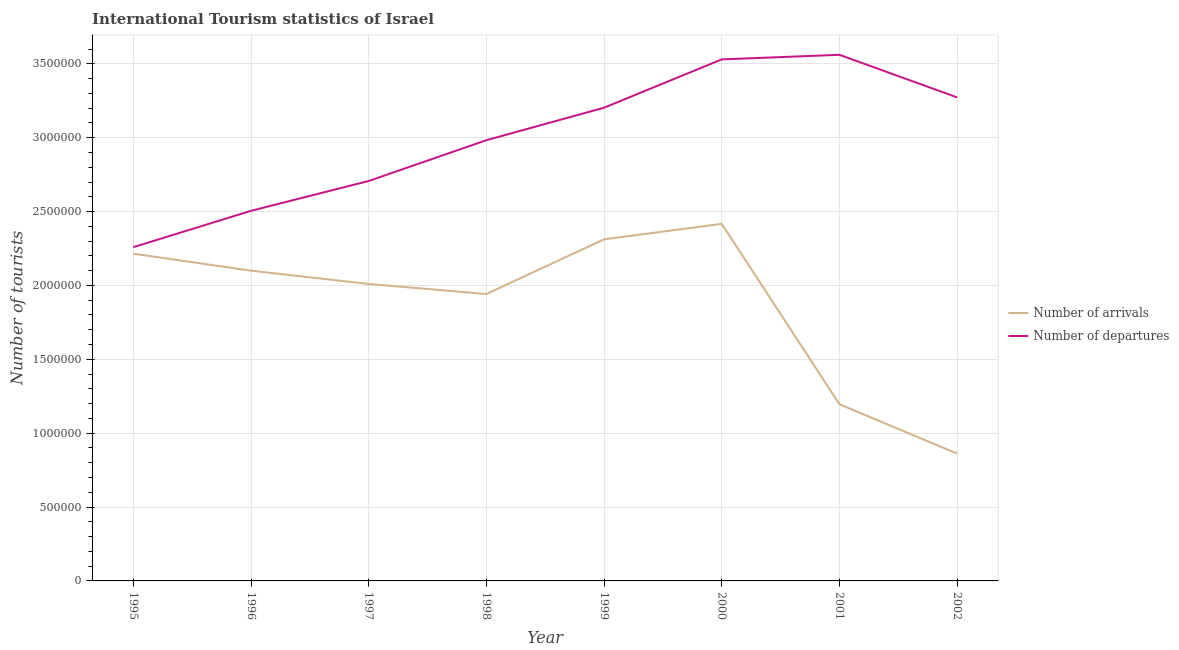What is the number of tourist arrivals in 1999?
Your response must be concise. 2.31e+06. Across all years, what is the maximum number of tourist arrivals?
Offer a very short reply. 2.42e+06. Across all years, what is the minimum number of tourist arrivals?
Provide a short and direct response. 8.62e+05. In which year was the number of tourist departures maximum?
Your response must be concise. 2001. In which year was the number of tourist arrivals minimum?
Provide a succinct answer. 2002. What is the total number of tourist departures in the graph?
Give a very brief answer. 2.40e+07. What is the difference between the number of tourist arrivals in 1995 and that in 2002?
Your answer should be compact. 1.35e+06. What is the difference between the number of tourist arrivals in 1997 and the number of tourist departures in 2002?
Provide a short and direct response. -1.26e+06. What is the average number of tourist arrivals per year?
Your answer should be compact. 1.88e+06. In the year 2001, what is the difference between the number of tourist arrivals and number of tourist departures?
Your answer should be compact. -2.36e+06. In how many years, is the number of tourist departures greater than 300000?
Provide a short and direct response. 8. What is the ratio of the number of tourist arrivals in 2001 to that in 2002?
Ensure brevity in your answer.  1.39. Is the difference between the number of tourist arrivals in 1999 and 2001 greater than the difference between the number of tourist departures in 1999 and 2001?
Give a very brief answer. Yes. What is the difference between the highest and the second highest number of tourist arrivals?
Provide a succinct answer. 1.05e+05. What is the difference between the highest and the lowest number of tourist departures?
Give a very brief answer. 1.30e+06. Is the sum of the number of tourist departures in 1997 and 1999 greater than the maximum number of tourist arrivals across all years?
Ensure brevity in your answer.  Yes. Does the number of tourist departures monotonically increase over the years?
Your answer should be very brief. No. Is the number of tourist arrivals strictly less than the number of tourist departures over the years?
Give a very brief answer. Yes. How many lines are there?
Your response must be concise. 2. How many years are there in the graph?
Provide a short and direct response. 8. What is the difference between two consecutive major ticks on the Y-axis?
Your answer should be very brief. 5.00e+05. Does the graph contain any zero values?
Your answer should be very brief. No. Does the graph contain grids?
Provide a short and direct response. Yes. Where does the legend appear in the graph?
Provide a short and direct response. Center right. How many legend labels are there?
Your answer should be very brief. 2. How are the legend labels stacked?
Keep it short and to the point. Vertical. What is the title of the graph?
Ensure brevity in your answer.  International Tourism statistics of Israel. Does "Highest 10% of population" appear as one of the legend labels in the graph?
Your answer should be compact. No. What is the label or title of the Y-axis?
Keep it short and to the point. Number of tourists. What is the Number of tourists in Number of arrivals in 1995?
Offer a terse response. 2.22e+06. What is the Number of tourists of Number of departures in 1995?
Your answer should be very brief. 2.26e+06. What is the Number of tourists in Number of arrivals in 1996?
Your response must be concise. 2.10e+06. What is the Number of tourists in Number of departures in 1996?
Provide a succinct answer. 2.50e+06. What is the Number of tourists in Number of arrivals in 1997?
Your answer should be compact. 2.01e+06. What is the Number of tourists in Number of departures in 1997?
Keep it short and to the point. 2.71e+06. What is the Number of tourists of Number of arrivals in 1998?
Your answer should be compact. 1.94e+06. What is the Number of tourists of Number of departures in 1998?
Give a very brief answer. 2.98e+06. What is the Number of tourists in Number of arrivals in 1999?
Offer a terse response. 2.31e+06. What is the Number of tourists in Number of departures in 1999?
Your answer should be very brief. 3.20e+06. What is the Number of tourists in Number of arrivals in 2000?
Offer a very short reply. 2.42e+06. What is the Number of tourists in Number of departures in 2000?
Make the answer very short. 3.53e+06. What is the Number of tourists in Number of arrivals in 2001?
Offer a terse response. 1.20e+06. What is the Number of tourists in Number of departures in 2001?
Your response must be concise. 3.56e+06. What is the Number of tourists in Number of arrivals in 2002?
Ensure brevity in your answer.  8.62e+05. What is the Number of tourists in Number of departures in 2002?
Provide a succinct answer. 3.27e+06. Across all years, what is the maximum Number of tourists in Number of arrivals?
Offer a very short reply. 2.42e+06. Across all years, what is the maximum Number of tourists of Number of departures?
Provide a succinct answer. 3.56e+06. Across all years, what is the minimum Number of tourists of Number of arrivals?
Offer a terse response. 8.62e+05. Across all years, what is the minimum Number of tourists in Number of departures?
Offer a very short reply. 2.26e+06. What is the total Number of tourists in Number of arrivals in the graph?
Keep it short and to the point. 1.51e+07. What is the total Number of tourists in Number of departures in the graph?
Your response must be concise. 2.40e+07. What is the difference between the Number of tourists in Number of arrivals in 1995 and that in 1996?
Your response must be concise. 1.15e+05. What is the difference between the Number of tourists in Number of departures in 1995 and that in 1996?
Your answer should be very brief. -2.46e+05. What is the difference between the Number of tourists in Number of arrivals in 1995 and that in 1997?
Your answer should be very brief. 2.05e+05. What is the difference between the Number of tourists of Number of departures in 1995 and that in 1997?
Provide a succinct answer. -4.48e+05. What is the difference between the Number of tourists of Number of arrivals in 1995 and that in 1998?
Give a very brief answer. 2.73e+05. What is the difference between the Number of tourists of Number of departures in 1995 and that in 1998?
Provide a short and direct response. -7.24e+05. What is the difference between the Number of tourists of Number of arrivals in 1995 and that in 1999?
Ensure brevity in your answer.  -9.70e+04. What is the difference between the Number of tourists in Number of departures in 1995 and that in 1999?
Your answer should be very brief. -9.44e+05. What is the difference between the Number of tourists in Number of arrivals in 1995 and that in 2000?
Make the answer very short. -2.02e+05. What is the difference between the Number of tourists in Number of departures in 1995 and that in 2000?
Ensure brevity in your answer.  -1.27e+06. What is the difference between the Number of tourists of Number of arrivals in 1995 and that in 2001?
Offer a terse response. 1.02e+06. What is the difference between the Number of tourists of Number of departures in 1995 and that in 2001?
Make the answer very short. -1.30e+06. What is the difference between the Number of tourists of Number of arrivals in 1995 and that in 2002?
Provide a succinct answer. 1.35e+06. What is the difference between the Number of tourists in Number of departures in 1995 and that in 2002?
Your answer should be very brief. -1.01e+06. What is the difference between the Number of tourists of Number of departures in 1996 and that in 1997?
Your answer should be compact. -2.02e+05. What is the difference between the Number of tourists in Number of arrivals in 1996 and that in 1998?
Keep it short and to the point. 1.58e+05. What is the difference between the Number of tourists in Number of departures in 1996 and that in 1998?
Your answer should be compact. -4.78e+05. What is the difference between the Number of tourists of Number of arrivals in 1996 and that in 1999?
Your answer should be compact. -2.12e+05. What is the difference between the Number of tourists in Number of departures in 1996 and that in 1999?
Your answer should be very brief. -6.98e+05. What is the difference between the Number of tourists of Number of arrivals in 1996 and that in 2000?
Provide a succinct answer. -3.17e+05. What is the difference between the Number of tourists in Number of departures in 1996 and that in 2000?
Offer a very short reply. -1.02e+06. What is the difference between the Number of tourists in Number of arrivals in 1996 and that in 2001?
Keep it short and to the point. 9.04e+05. What is the difference between the Number of tourists in Number of departures in 1996 and that in 2001?
Make the answer very short. -1.06e+06. What is the difference between the Number of tourists of Number of arrivals in 1996 and that in 2002?
Make the answer very short. 1.24e+06. What is the difference between the Number of tourists in Number of departures in 1996 and that in 2002?
Give a very brief answer. -7.68e+05. What is the difference between the Number of tourists of Number of arrivals in 1997 and that in 1998?
Your response must be concise. 6.80e+04. What is the difference between the Number of tourists of Number of departures in 1997 and that in 1998?
Provide a short and direct response. -2.76e+05. What is the difference between the Number of tourists of Number of arrivals in 1997 and that in 1999?
Keep it short and to the point. -3.02e+05. What is the difference between the Number of tourists in Number of departures in 1997 and that in 1999?
Your answer should be very brief. -4.96e+05. What is the difference between the Number of tourists of Number of arrivals in 1997 and that in 2000?
Make the answer very short. -4.07e+05. What is the difference between the Number of tourists of Number of departures in 1997 and that in 2000?
Make the answer very short. -8.23e+05. What is the difference between the Number of tourists of Number of arrivals in 1997 and that in 2001?
Offer a very short reply. 8.14e+05. What is the difference between the Number of tourists of Number of departures in 1997 and that in 2001?
Offer a terse response. -8.54e+05. What is the difference between the Number of tourists of Number of arrivals in 1997 and that in 2002?
Ensure brevity in your answer.  1.15e+06. What is the difference between the Number of tourists in Number of departures in 1997 and that in 2002?
Provide a succinct answer. -5.66e+05. What is the difference between the Number of tourists in Number of arrivals in 1998 and that in 1999?
Ensure brevity in your answer.  -3.70e+05. What is the difference between the Number of tourists of Number of arrivals in 1998 and that in 2000?
Ensure brevity in your answer.  -4.75e+05. What is the difference between the Number of tourists of Number of departures in 1998 and that in 2000?
Your response must be concise. -5.47e+05. What is the difference between the Number of tourists of Number of arrivals in 1998 and that in 2001?
Ensure brevity in your answer.  7.46e+05. What is the difference between the Number of tourists of Number of departures in 1998 and that in 2001?
Your answer should be compact. -5.78e+05. What is the difference between the Number of tourists of Number of arrivals in 1998 and that in 2002?
Provide a short and direct response. 1.08e+06. What is the difference between the Number of tourists of Number of arrivals in 1999 and that in 2000?
Provide a succinct answer. -1.05e+05. What is the difference between the Number of tourists of Number of departures in 1999 and that in 2000?
Provide a succinct answer. -3.27e+05. What is the difference between the Number of tourists of Number of arrivals in 1999 and that in 2001?
Give a very brief answer. 1.12e+06. What is the difference between the Number of tourists of Number of departures in 1999 and that in 2001?
Your answer should be compact. -3.58e+05. What is the difference between the Number of tourists of Number of arrivals in 1999 and that in 2002?
Ensure brevity in your answer.  1.45e+06. What is the difference between the Number of tourists in Number of arrivals in 2000 and that in 2001?
Give a very brief answer. 1.22e+06. What is the difference between the Number of tourists in Number of departures in 2000 and that in 2001?
Provide a succinct answer. -3.10e+04. What is the difference between the Number of tourists in Number of arrivals in 2000 and that in 2002?
Keep it short and to the point. 1.56e+06. What is the difference between the Number of tourists of Number of departures in 2000 and that in 2002?
Keep it short and to the point. 2.57e+05. What is the difference between the Number of tourists in Number of arrivals in 2001 and that in 2002?
Make the answer very short. 3.34e+05. What is the difference between the Number of tourists of Number of departures in 2001 and that in 2002?
Give a very brief answer. 2.88e+05. What is the difference between the Number of tourists of Number of arrivals in 1995 and the Number of tourists of Number of departures in 1996?
Your answer should be very brief. -2.90e+05. What is the difference between the Number of tourists in Number of arrivals in 1995 and the Number of tourists in Number of departures in 1997?
Provide a succinct answer. -4.92e+05. What is the difference between the Number of tourists of Number of arrivals in 1995 and the Number of tourists of Number of departures in 1998?
Your answer should be compact. -7.68e+05. What is the difference between the Number of tourists of Number of arrivals in 1995 and the Number of tourists of Number of departures in 1999?
Provide a short and direct response. -9.88e+05. What is the difference between the Number of tourists in Number of arrivals in 1995 and the Number of tourists in Number of departures in 2000?
Your answer should be very brief. -1.32e+06. What is the difference between the Number of tourists in Number of arrivals in 1995 and the Number of tourists in Number of departures in 2001?
Your answer should be compact. -1.35e+06. What is the difference between the Number of tourists of Number of arrivals in 1995 and the Number of tourists of Number of departures in 2002?
Keep it short and to the point. -1.06e+06. What is the difference between the Number of tourists in Number of arrivals in 1996 and the Number of tourists in Number of departures in 1997?
Make the answer very short. -6.07e+05. What is the difference between the Number of tourists in Number of arrivals in 1996 and the Number of tourists in Number of departures in 1998?
Ensure brevity in your answer.  -8.83e+05. What is the difference between the Number of tourists of Number of arrivals in 1996 and the Number of tourists of Number of departures in 1999?
Offer a terse response. -1.10e+06. What is the difference between the Number of tourists of Number of arrivals in 1996 and the Number of tourists of Number of departures in 2000?
Your answer should be very brief. -1.43e+06. What is the difference between the Number of tourists in Number of arrivals in 1996 and the Number of tourists in Number of departures in 2001?
Offer a very short reply. -1.46e+06. What is the difference between the Number of tourists of Number of arrivals in 1996 and the Number of tourists of Number of departures in 2002?
Your answer should be very brief. -1.17e+06. What is the difference between the Number of tourists of Number of arrivals in 1997 and the Number of tourists of Number of departures in 1998?
Provide a short and direct response. -9.73e+05. What is the difference between the Number of tourists in Number of arrivals in 1997 and the Number of tourists in Number of departures in 1999?
Provide a succinct answer. -1.19e+06. What is the difference between the Number of tourists of Number of arrivals in 1997 and the Number of tourists of Number of departures in 2000?
Offer a very short reply. -1.52e+06. What is the difference between the Number of tourists of Number of arrivals in 1997 and the Number of tourists of Number of departures in 2001?
Ensure brevity in your answer.  -1.55e+06. What is the difference between the Number of tourists in Number of arrivals in 1997 and the Number of tourists in Number of departures in 2002?
Make the answer very short. -1.26e+06. What is the difference between the Number of tourists of Number of arrivals in 1998 and the Number of tourists of Number of departures in 1999?
Your answer should be very brief. -1.26e+06. What is the difference between the Number of tourists in Number of arrivals in 1998 and the Number of tourists in Number of departures in 2000?
Offer a terse response. -1.59e+06. What is the difference between the Number of tourists in Number of arrivals in 1998 and the Number of tourists in Number of departures in 2001?
Offer a terse response. -1.62e+06. What is the difference between the Number of tourists of Number of arrivals in 1998 and the Number of tourists of Number of departures in 2002?
Your answer should be compact. -1.33e+06. What is the difference between the Number of tourists of Number of arrivals in 1999 and the Number of tourists of Number of departures in 2000?
Give a very brief answer. -1.22e+06. What is the difference between the Number of tourists of Number of arrivals in 1999 and the Number of tourists of Number of departures in 2001?
Provide a succinct answer. -1.25e+06. What is the difference between the Number of tourists in Number of arrivals in 1999 and the Number of tourists in Number of departures in 2002?
Provide a short and direct response. -9.61e+05. What is the difference between the Number of tourists of Number of arrivals in 2000 and the Number of tourists of Number of departures in 2001?
Your response must be concise. -1.14e+06. What is the difference between the Number of tourists in Number of arrivals in 2000 and the Number of tourists in Number of departures in 2002?
Keep it short and to the point. -8.56e+05. What is the difference between the Number of tourists in Number of arrivals in 2001 and the Number of tourists in Number of departures in 2002?
Your response must be concise. -2.08e+06. What is the average Number of tourists of Number of arrivals per year?
Offer a very short reply. 1.88e+06. What is the average Number of tourists in Number of departures per year?
Provide a succinct answer. 3.00e+06. In the year 1995, what is the difference between the Number of tourists in Number of arrivals and Number of tourists in Number of departures?
Ensure brevity in your answer.  -4.40e+04. In the year 1996, what is the difference between the Number of tourists of Number of arrivals and Number of tourists of Number of departures?
Provide a short and direct response. -4.05e+05. In the year 1997, what is the difference between the Number of tourists of Number of arrivals and Number of tourists of Number of departures?
Provide a succinct answer. -6.97e+05. In the year 1998, what is the difference between the Number of tourists of Number of arrivals and Number of tourists of Number of departures?
Make the answer very short. -1.04e+06. In the year 1999, what is the difference between the Number of tourists of Number of arrivals and Number of tourists of Number of departures?
Ensure brevity in your answer.  -8.91e+05. In the year 2000, what is the difference between the Number of tourists of Number of arrivals and Number of tourists of Number of departures?
Ensure brevity in your answer.  -1.11e+06. In the year 2001, what is the difference between the Number of tourists of Number of arrivals and Number of tourists of Number of departures?
Ensure brevity in your answer.  -2.36e+06. In the year 2002, what is the difference between the Number of tourists of Number of arrivals and Number of tourists of Number of departures?
Your answer should be compact. -2.41e+06. What is the ratio of the Number of tourists in Number of arrivals in 1995 to that in 1996?
Give a very brief answer. 1.05. What is the ratio of the Number of tourists of Number of departures in 1995 to that in 1996?
Your response must be concise. 0.9. What is the ratio of the Number of tourists of Number of arrivals in 1995 to that in 1997?
Offer a very short reply. 1.1. What is the ratio of the Number of tourists of Number of departures in 1995 to that in 1997?
Your response must be concise. 0.83. What is the ratio of the Number of tourists in Number of arrivals in 1995 to that in 1998?
Offer a very short reply. 1.14. What is the ratio of the Number of tourists of Number of departures in 1995 to that in 1998?
Give a very brief answer. 0.76. What is the ratio of the Number of tourists in Number of arrivals in 1995 to that in 1999?
Ensure brevity in your answer.  0.96. What is the ratio of the Number of tourists in Number of departures in 1995 to that in 1999?
Your answer should be very brief. 0.71. What is the ratio of the Number of tourists in Number of arrivals in 1995 to that in 2000?
Your answer should be very brief. 0.92. What is the ratio of the Number of tourists of Number of departures in 1995 to that in 2000?
Your answer should be compact. 0.64. What is the ratio of the Number of tourists of Number of arrivals in 1995 to that in 2001?
Offer a terse response. 1.85. What is the ratio of the Number of tourists in Number of departures in 1995 to that in 2001?
Give a very brief answer. 0.63. What is the ratio of the Number of tourists of Number of arrivals in 1995 to that in 2002?
Offer a terse response. 2.57. What is the ratio of the Number of tourists of Number of departures in 1995 to that in 2002?
Keep it short and to the point. 0.69. What is the ratio of the Number of tourists in Number of arrivals in 1996 to that in 1997?
Offer a very short reply. 1.04. What is the ratio of the Number of tourists in Number of departures in 1996 to that in 1997?
Ensure brevity in your answer.  0.93. What is the ratio of the Number of tourists of Number of arrivals in 1996 to that in 1998?
Keep it short and to the point. 1.08. What is the ratio of the Number of tourists in Number of departures in 1996 to that in 1998?
Give a very brief answer. 0.84. What is the ratio of the Number of tourists in Number of arrivals in 1996 to that in 1999?
Your answer should be compact. 0.91. What is the ratio of the Number of tourists of Number of departures in 1996 to that in 1999?
Offer a very short reply. 0.78. What is the ratio of the Number of tourists of Number of arrivals in 1996 to that in 2000?
Provide a succinct answer. 0.87. What is the ratio of the Number of tourists of Number of departures in 1996 to that in 2000?
Keep it short and to the point. 0.71. What is the ratio of the Number of tourists of Number of arrivals in 1996 to that in 2001?
Ensure brevity in your answer.  1.76. What is the ratio of the Number of tourists in Number of departures in 1996 to that in 2001?
Provide a short and direct response. 0.7. What is the ratio of the Number of tourists in Number of arrivals in 1996 to that in 2002?
Your response must be concise. 2.44. What is the ratio of the Number of tourists of Number of departures in 1996 to that in 2002?
Provide a succinct answer. 0.77. What is the ratio of the Number of tourists of Number of arrivals in 1997 to that in 1998?
Ensure brevity in your answer.  1.03. What is the ratio of the Number of tourists in Number of departures in 1997 to that in 1998?
Provide a succinct answer. 0.91. What is the ratio of the Number of tourists in Number of arrivals in 1997 to that in 1999?
Provide a short and direct response. 0.87. What is the ratio of the Number of tourists of Number of departures in 1997 to that in 1999?
Offer a very short reply. 0.85. What is the ratio of the Number of tourists in Number of arrivals in 1997 to that in 2000?
Ensure brevity in your answer.  0.83. What is the ratio of the Number of tourists of Number of departures in 1997 to that in 2000?
Your response must be concise. 0.77. What is the ratio of the Number of tourists in Number of arrivals in 1997 to that in 2001?
Give a very brief answer. 1.68. What is the ratio of the Number of tourists in Number of departures in 1997 to that in 2001?
Give a very brief answer. 0.76. What is the ratio of the Number of tourists in Number of arrivals in 1997 to that in 2002?
Give a very brief answer. 2.33. What is the ratio of the Number of tourists in Number of departures in 1997 to that in 2002?
Your response must be concise. 0.83. What is the ratio of the Number of tourists in Number of arrivals in 1998 to that in 1999?
Your response must be concise. 0.84. What is the ratio of the Number of tourists in Number of departures in 1998 to that in 1999?
Your response must be concise. 0.93. What is the ratio of the Number of tourists in Number of arrivals in 1998 to that in 2000?
Offer a very short reply. 0.8. What is the ratio of the Number of tourists in Number of departures in 1998 to that in 2000?
Your response must be concise. 0.84. What is the ratio of the Number of tourists in Number of arrivals in 1998 to that in 2001?
Keep it short and to the point. 1.62. What is the ratio of the Number of tourists of Number of departures in 1998 to that in 2001?
Provide a succinct answer. 0.84. What is the ratio of the Number of tourists in Number of arrivals in 1998 to that in 2002?
Offer a terse response. 2.25. What is the ratio of the Number of tourists in Number of departures in 1998 to that in 2002?
Offer a terse response. 0.91. What is the ratio of the Number of tourists of Number of arrivals in 1999 to that in 2000?
Your answer should be compact. 0.96. What is the ratio of the Number of tourists in Number of departures in 1999 to that in 2000?
Offer a very short reply. 0.91. What is the ratio of the Number of tourists in Number of arrivals in 1999 to that in 2001?
Provide a succinct answer. 1.93. What is the ratio of the Number of tourists in Number of departures in 1999 to that in 2001?
Your answer should be compact. 0.9. What is the ratio of the Number of tourists of Number of arrivals in 1999 to that in 2002?
Offer a terse response. 2.68. What is the ratio of the Number of tourists of Number of departures in 1999 to that in 2002?
Your response must be concise. 0.98. What is the ratio of the Number of tourists in Number of arrivals in 2000 to that in 2001?
Ensure brevity in your answer.  2.02. What is the ratio of the Number of tourists of Number of departures in 2000 to that in 2001?
Provide a succinct answer. 0.99. What is the ratio of the Number of tourists of Number of arrivals in 2000 to that in 2002?
Offer a terse response. 2.8. What is the ratio of the Number of tourists in Number of departures in 2000 to that in 2002?
Make the answer very short. 1.08. What is the ratio of the Number of tourists in Number of arrivals in 2001 to that in 2002?
Offer a very short reply. 1.39. What is the ratio of the Number of tourists of Number of departures in 2001 to that in 2002?
Give a very brief answer. 1.09. What is the difference between the highest and the second highest Number of tourists in Number of arrivals?
Provide a succinct answer. 1.05e+05. What is the difference between the highest and the second highest Number of tourists of Number of departures?
Give a very brief answer. 3.10e+04. What is the difference between the highest and the lowest Number of tourists in Number of arrivals?
Make the answer very short. 1.56e+06. What is the difference between the highest and the lowest Number of tourists in Number of departures?
Make the answer very short. 1.30e+06. 